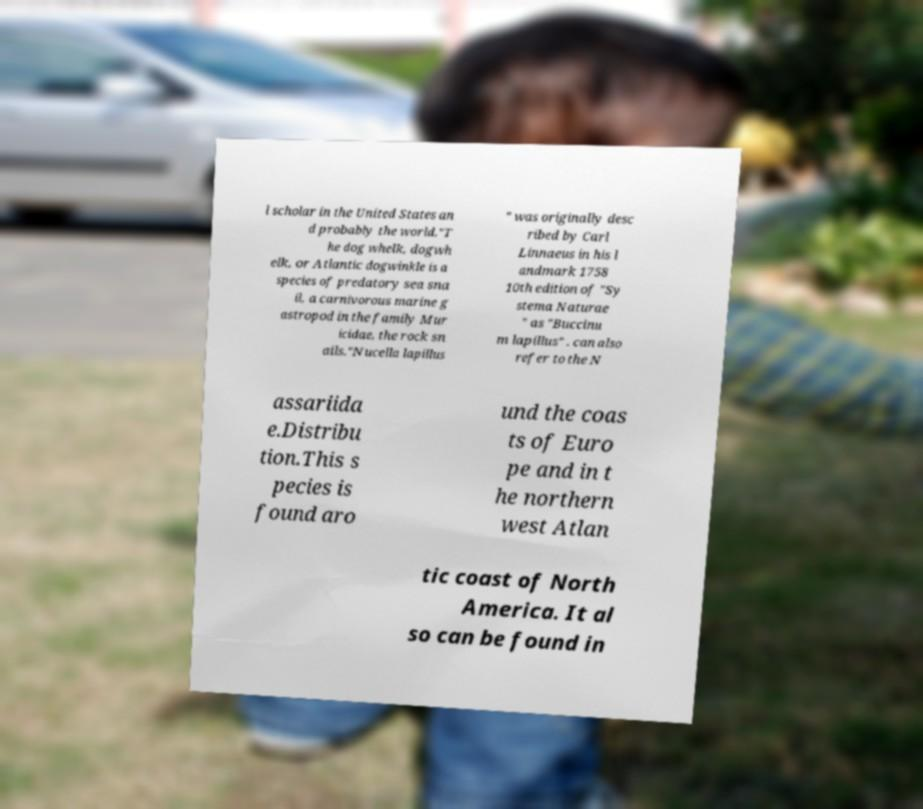What messages or text are displayed in this image? I need them in a readable, typed format. l scholar in the United States an d probably the world."T he dog whelk, dogwh elk, or Atlantic dogwinkle is a species of predatory sea sna il, a carnivorous marine g astropod in the family Mur icidae, the rock sn ails."Nucella lapillus " was originally desc ribed by Carl Linnaeus in his l andmark 1758 10th edition of "Sy stema Naturae " as "Buccinu m lapillus" . can also refer to the N assariida e.Distribu tion.This s pecies is found aro und the coas ts of Euro pe and in t he northern west Atlan tic coast of North America. It al so can be found in 